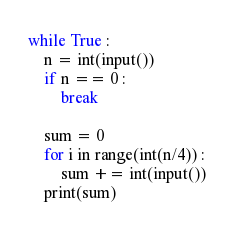Convert code to text. <code><loc_0><loc_0><loc_500><loc_500><_Python_>while True :
    n = int(input())
    if n == 0 :
        break
    
    sum = 0
    for i in range(int(n/4)) :
        sum += int(input())
    print(sum)
</code> 